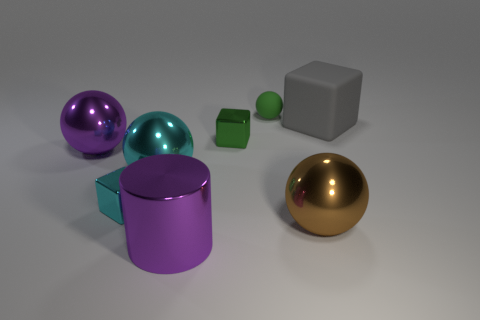Subtract all metal cubes. How many cubes are left? 1 Add 2 gray rubber cubes. How many objects exist? 10 Subtract all cubes. How many objects are left? 5 Subtract all yellow cylinders. How many cyan balls are left? 1 Subtract all green balls. How many balls are left? 3 Subtract 1 purple spheres. How many objects are left? 7 Subtract 3 balls. How many balls are left? 1 Subtract all purple balls. Subtract all purple blocks. How many balls are left? 3 Subtract all large cyan metal balls. Subtract all matte spheres. How many objects are left? 6 Add 6 small rubber things. How many small rubber things are left? 7 